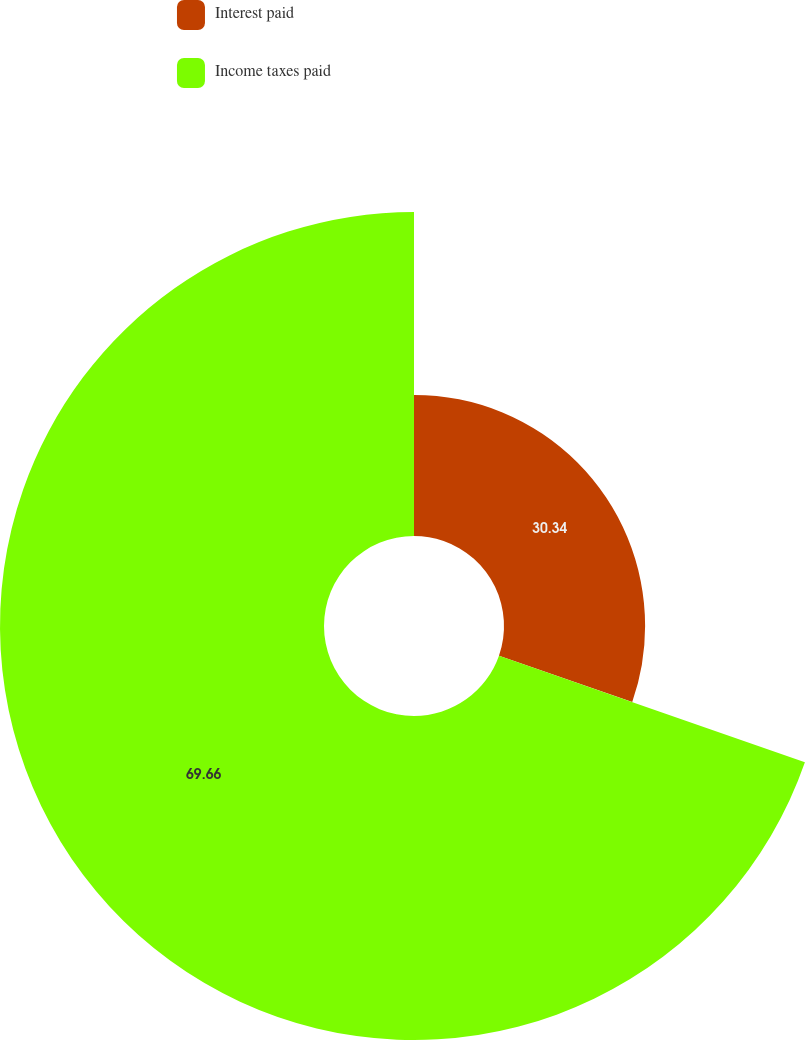<chart> <loc_0><loc_0><loc_500><loc_500><pie_chart><fcel>Interest paid<fcel>Income taxes paid<nl><fcel>30.34%<fcel>69.66%<nl></chart> 